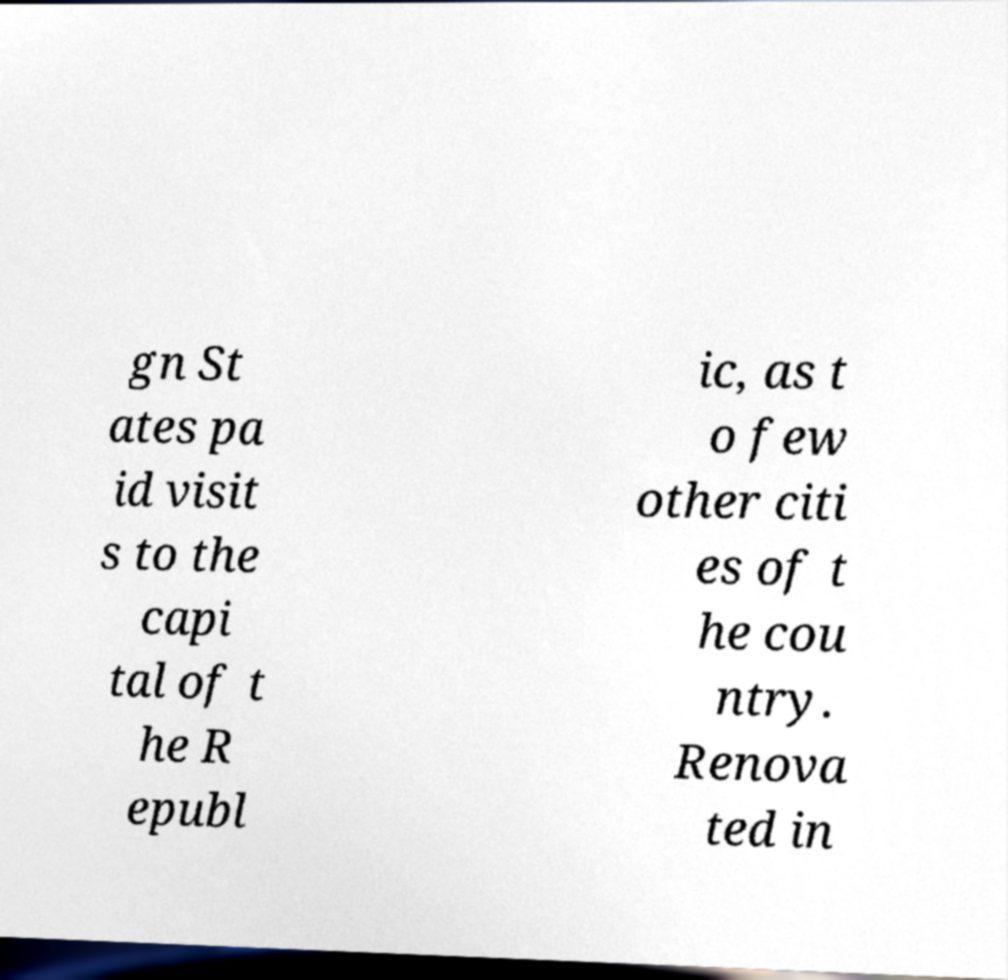Please identify and transcribe the text found in this image. gn St ates pa id visit s to the capi tal of t he R epubl ic, as t o few other citi es of t he cou ntry. Renova ted in 